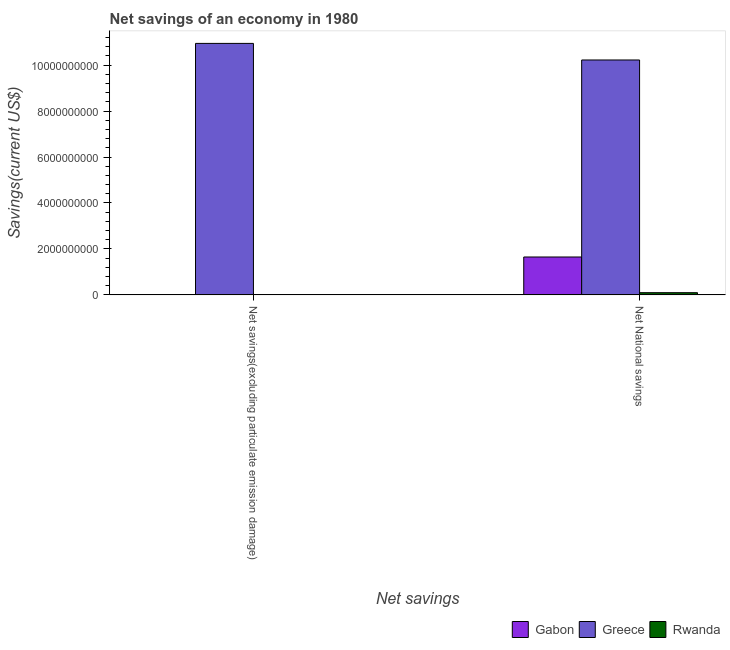How many different coloured bars are there?
Give a very brief answer. 3. Are the number of bars per tick equal to the number of legend labels?
Your answer should be very brief. No. Are the number of bars on each tick of the X-axis equal?
Provide a short and direct response. No. How many bars are there on the 1st tick from the left?
Provide a succinct answer. 2. How many bars are there on the 2nd tick from the right?
Your answer should be compact. 2. What is the label of the 1st group of bars from the left?
Offer a very short reply. Net savings(excluding particulate emission damage). What is the net national savings in Greece?
Offer a very short reply. 1.02e+1. Across all countries, what is the maximum net national savings?
Provide a succinct answer. 1.02e+1. Across all countries, what is the minimum net national savings?
Provide a succinct answer. 9.61e+07. What is the total net national savings in the graph?
Keep it short and to the point. 1.20e+1. What is the difference between the net national savings in Greece and that in Rwanda?
Your response must be concise. 1.01e+1. What is the difference between the net national savings in Rwanda and the net savings(excluding particulate emission damage) in Gabon?
Offer a terse response. 9.61e+07. What is the average net savings(excluding particulate emission damage) per country?
Provide a succinct answer. 3.65e+09. What is the difference between the net national savings and net savings(excluding particulate emission damage) in Greece?
Provide a succinct answer. -7.22e+08. What is the ratio of the net savings(excluding particulate emission damage) in Greece to that in Rwanda?
Ensure brevity in your answer.  854.66. Is the net national savings in Greece less than that in Gabon?
Offer a very short reply. No. How many bars are there?
Your response must be concise. 5. Are the values on the major ticks of Y-axis written in scientific E-notation?
Give a very brief answer. No. Where does the legend appear in the graph?
Give a very brief answer. Bottom right. How many legend labels are there?
Provide a short and direct response. 3. How are the legend labels stacked?
Offer a very short reply. Horizontal. What is the title of the graph?
Ensure brevity in your answer.  Net savings of an economy in 1980. Does "Congo (Democratic)" appear as one of the legend labels in the graph?
Provide a short and direct response. No. What is the label or title of the X-axis?
Ensure brevity in your answer.  Net savings. What is the label or title of the Y-axis?
Offer a terse response. Savings(current US$). What is the Savings(current US$) of Gabon in Net savings(excluding particulate emission damage)?
Offer a very short reply. 0. What is the Savings(current US$) of Greece in Net savings(excluding particulate emission damage)?
Your response must be concise. 1.09e+1. What is the Savings(current US$) of Rwanda in Net savings(excluding particulate emission damage)?
Your response must be concise. 1.28e+07. What is the Savings(current US$) of Gabon in Net National savings?
Your response must be concise. 1.65e+09. What is the Savings(current US$) in Greece in Net National savings?
Provide a short and direct response. 1.02e+1. What is the Savings(current US$) in Rwanda in Net National savings?
Keep it short and to the point. 9.61e+07. Across all Net savings, what is the maximum Savings(current US$) of Gabon?
Your answer should be very brief. 1.65e+09. Across all Net savings, what is the maximum Savings(current US$) of Greece?
Make the answer very short. 1.09e+1. Across all Net savings, what is the maximum Savings(current US$) in Rwanda?
Your answer should be very brief. 9.61e+07. Across all Net savings, what is the minimum Savings(current US$) in Greece?
Give a very brief answer. 1.02e+1. Across all Net savings, what is the minimum Savings(current US$) of Rwanda?
Offer a terse response. 1.28e+07. What is the total Savings(current US$) in Gabon in the graph?
Keep it short and to the point. 1.65e+09. What is the total Savings(current US$) in Greece in the graph?
Ensure brevity in your answer.  2.12e+1. What is the total Savings(current US$) of Rwanda in the graph?
Offer a terse response. 1.09e+08. What is the difference between the Savings(current US$) of Greece in Net savings(excluding particulate emission damage) and that in Net National savings?
Give a very brief answer. 7.22e+08. What is the difference between the Savings(current US$) in Rwanda in Net savings(excluding particulate emission damage) and that in Net National savings?
Provide a succinct answer. -8.32e+07. What is the difference between the Savings(current US$) of Greece in Net savings(excluding particulate emission damage) and the Savings(current US$) of Rwanda in Net National savings?
Your answer should be very brief. 1.09e+1. What is the average Savings(current US$) in Gabon per Net savings?
Provide a short and direct response. 8.25e+08. What is the average Savings(current US$) of Greece per Net savings?
Offer a very short reply. 1.06e+1. What is the average Savings(current US$) of Rwanda per Net savings?
Your answer should be compact. 5.44e+07. What is the difference between the Savings(current US$) in Greece and Savings(current US$) in Rwanda in Net savings(excluding particulate emission damage)?
Your answer should be compact. 1.09e+1. What is the difference between the Savings(current US$) of Gabon and Savings(current US$) of Greece in Net National savings?
Provide a short and direct response. -8.57e+09. What is the difference between the Savings(current US$) in Gabon and Savings(current US$) in Rwanda in Net National savings?
Keep it short and to the point. 1.55e+09. What is the difference between the Savings(current US$) in Greece and Savings(current US$) in Rwanda in Net National savings?
Offer a terse response. 1.01e+1. What is the ratio of the Savings(current US$) of Greece in Net savings(excluding particulate emission damage) to that in Net National savings?
Keep it short and to the point. 1.07. What is the ratio of the Savings(current US$) in Rwanda in Net savings(excluding particulate emission damage) to that in Net National savings?
Your answer should be compact. 0.13. What is the difference between the highest and the second highest Savings(current US$) of Greece?
Your answer should be compact. 7.22e+08. What is the difference between the highest and the second highest Savings(current US$) of Rwanda?
Provide a short and direct response. 8.32e+07. What is the difference between the highest and the lowest Savings(current US$) of Gabon?
Your response must be concise. 1.65e+09. What is the difference between the highest and the lowest Savings(current US$) in Greece?
Your response must be concise. 7.22e+08. What is the difference between the highest and the lowest Savings(current US$) of Rwanda?
Keep it short and to the point. 8.32e+07. 